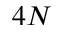Convert formula to latex. <formula><loc_0><loc_0><loc_500><loc_500>4 N</formula> 